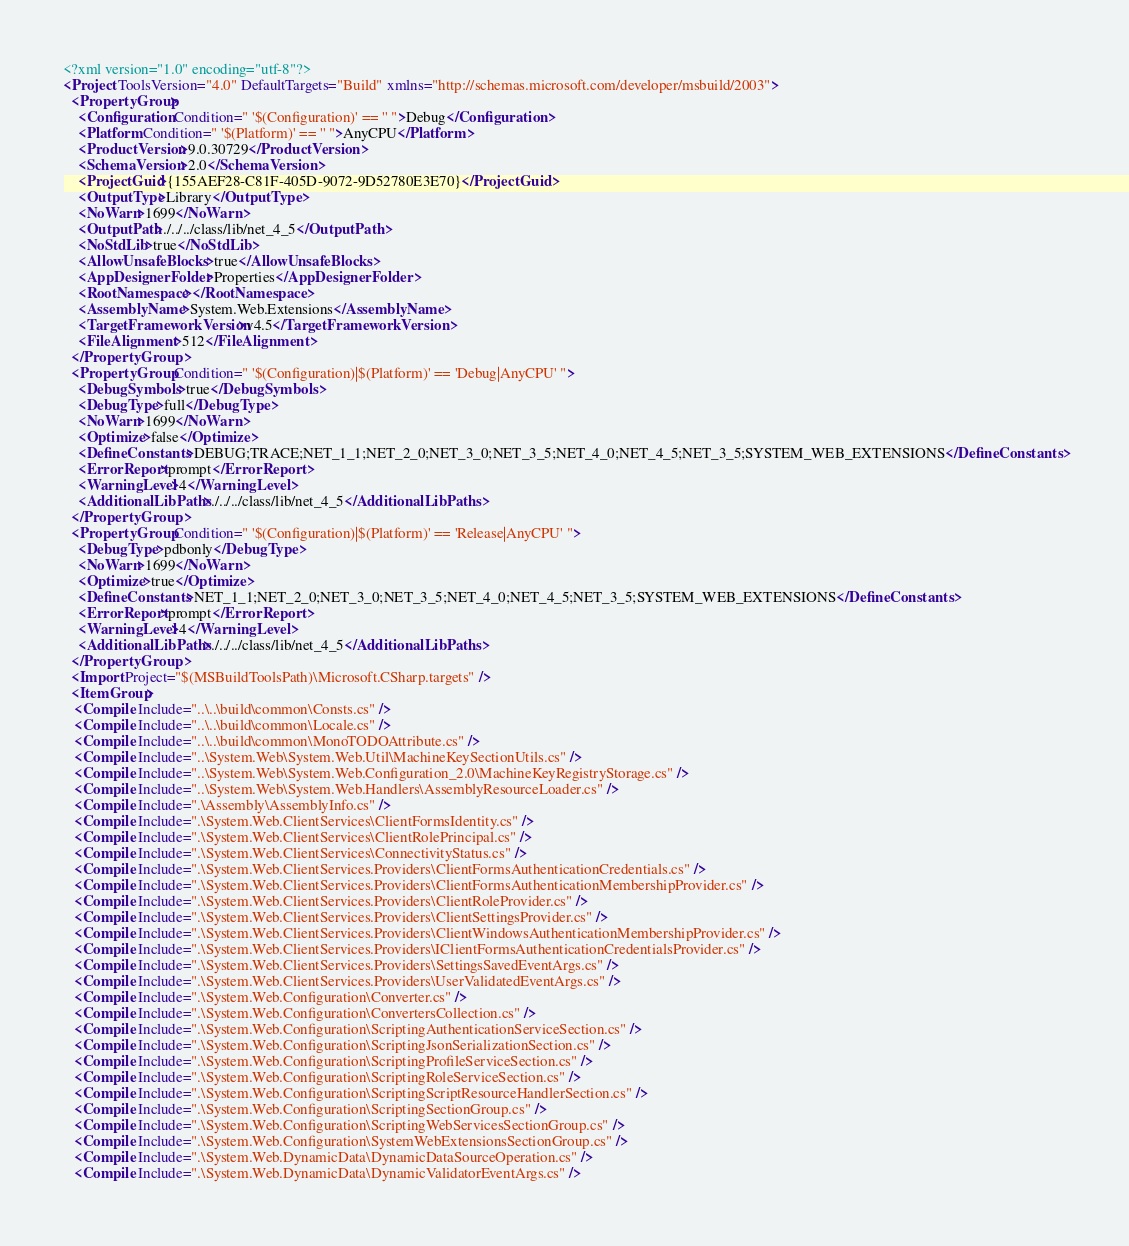Convert code to text. <code><loc_0><loc_0><loc_500><loc_500><_XML_><?xml version="1.0" encoding="utf-8"?>
<Project ToolsVersion="4.0" DefaultTargets="Build" xmlns="http://schemas.microsoft.com/developer/msbuild/2003">
  <PropertyGroup>
    <Configuration Condition=" '$(Configuration)' == '' ">Debug</Configuration>
    <Platform Condition=" '$(Platform)' == '' ">AnyCPU</Platform>
    <ProductVersion>9.0.30729</ProductVersion>
    <SchemaVersion>2.0</SchemaVersion>
    <ProjectGuid>{155AEF28-C81F-405D-9072-9D52780E3E70}</ProjectGuid>
    <OutputType>Library</OutputType>
    <NoWarn>1699</NoWarn>
    <OutputPath>./../../class/lib/net_4_5</OutputPath>
    <NoStdLib>true</NoStdLib>
    <AllowUnsafeBlocks>true</AllowUnsafeBlocks>
    <AppDesignerFolder>Properties</AppDesignerFolder>
    <RootNamespace></RootNamespace>
    <AssemblyName>System.Web.Extensions</AssemblyName>
    <TargetFrameworkVersion>v4.5</TargetFrameworkVersion>
    <FileAlignment>512</FileAlignment>
  </PropertyGroup>
  <PropertyGroup Condition=" '$(Configuration)|$(Platform)' == 'Debug|AnyCPU' ">
    <DebugSymbols>true</DebugSymbols>
    <DebugType>full</DebugType>
    <NoWarn>1699</NoWarn>
    <Optimize>false</Optimize>
    <DefineConstants>DEBUG;TRACE;NET_1_1;NET_2_0;NET_3_0;NET_3_5;NET_4_0;NET_4_5;NET_3_5;SYSTEM_WEB_EXTENSIONS</DefineConstants>
    <ErrorReport>prompt</ErrorReport>
    <WarningLevel>4</WarningLevel>
    <AdditionalLibPaths>./../../class/lib/net_4_5</AdditionalLibPaths>
  </PropertyGroup>
  <PropertyGroup Condition=" '$(Configuration)|$(Platform)' == 'Release|AnyCPU' ">
    <DebugType>pdbonly</DebugType>
    <NoWarn>1699</NoWarn>
    <Optimize>true</Optimize>
    <DefineConstants>NET_1_1;NET_2_0;NET_3_0;NET_3_5;NET_4_0;NET_4_5;NET_3_5;SYSTEM_WEB_EXTENSIONS</DefineConstants>
    <ErrorReport>prompt</ErrorReport>
    <WarningLevel>4</WarningLevel>
    <AdditionalLibPaths>./../../class/lib/net_4_5</AdditionalLibPaths>
  </PropertyGroup>
  <Import Project="$(MSBuildToolsPath)\Microsoft.CSharp.targets" />
  <ItemGroup>
   <Compile Include="..\..\build\common\Consts.cs" />
   <Compile Include="..\..\build\common\Locale.cs" />
   <Compile Include="..\..\build\common\MonoTODOAttribute.cs" />
   <Compile Include="..\System.Web\System.Web.Util\MachineKeySectionUtils.cs" />
   <Compile Include="..\System.Web\System.Web.Configuration_2.0\MachineKeyRegistryStorage.cs" />
   <Compile Include="..\System.Web\System.Web.Handlers\AssemblyResourceLoader.cs" />
   <Compile Include=".\Assembly\AssemblyInfo.cs" />
   <Compile Include=".\System.Web.ClientServices\ClientFormsIdentity.cs" />
   <Compile Include=".\System.Web.ClientServices\ClientRolePrincipal.cs" />
   <Compile Include=".\System.Web.ClientServices\ConnectivityStatus.cs" />
   <Compile Include=".\System.Web.ClientServices.Providers\ClientFormsAuthenticationCredentials.cs" />
   <Compile Include=".\System.Web.ClientServices.Providers\ClientFormsAuthenticationMembershipProvider.cs" />
   <Compile Include=".\System.Web.ClientServices.Providers\ClientRoleProvider.cs" />
   <Compile Include=".\System.Web.ClientServices.Providers\ClientSettingsProvider.cs" />
   <Compile Include=".\System.Web.ClientServices.Providers\ClientWindowsAuthenticationMembershipProvider.cs" />
   <Compile Include=".\System.Web.ClientServices.Providers\IClientFormsAuthenticationCredentialsProvider.cs" />
   <Compile Include=".\System.Web.ClientServices.Providers\SettingsSavedEventArgs.cs" />
   <Compile Include=".\System.Web.ClientServices.Providers\UserValidatedEventArgs.cs" />
   <Compile Include=".\System.Web.Configuration\Converter.cs" />
   <Compile Include=".\System.Web.Configuration\ConvertersCollection.cs" />
   <Compile Include=".\System.Web.Configuration\ScriptingAuthenticationServiceSection.cs" />
   <Compile Include=".\System.Web.Configuration\ScriptingJsonSerializationSection.cs" />
   <Compile Include=".\System.Web.Configuration\ScriptingProfileServiceSection.cs" />
   <Compile Include=".\System.Web.Configuration\ScriptingRoleServiceSection.cs" />
   <Compile Include=".\System.Web.Configuration\ScriptingScriptResourceHandlerSection.cs" />
   <Compile Include=".\System.Web.Configuration\ScriptingSectionGroup.cs" />
   <Compile Include=".\System.Web.Configuration\ScriptingWebServicesSectionGroup.cs" />
   <Compile Include=".\System.Web.Configuration\SystemWebExtensionsSectionGroup.cs" />
   <Compile Include=".\System.Web.DynamicData\DynamicDataSourceOperation.cs" />
   <Compile Include=".\System.Web.DynamicData\DynamicValidatorEventArgs.cs" /></code> 